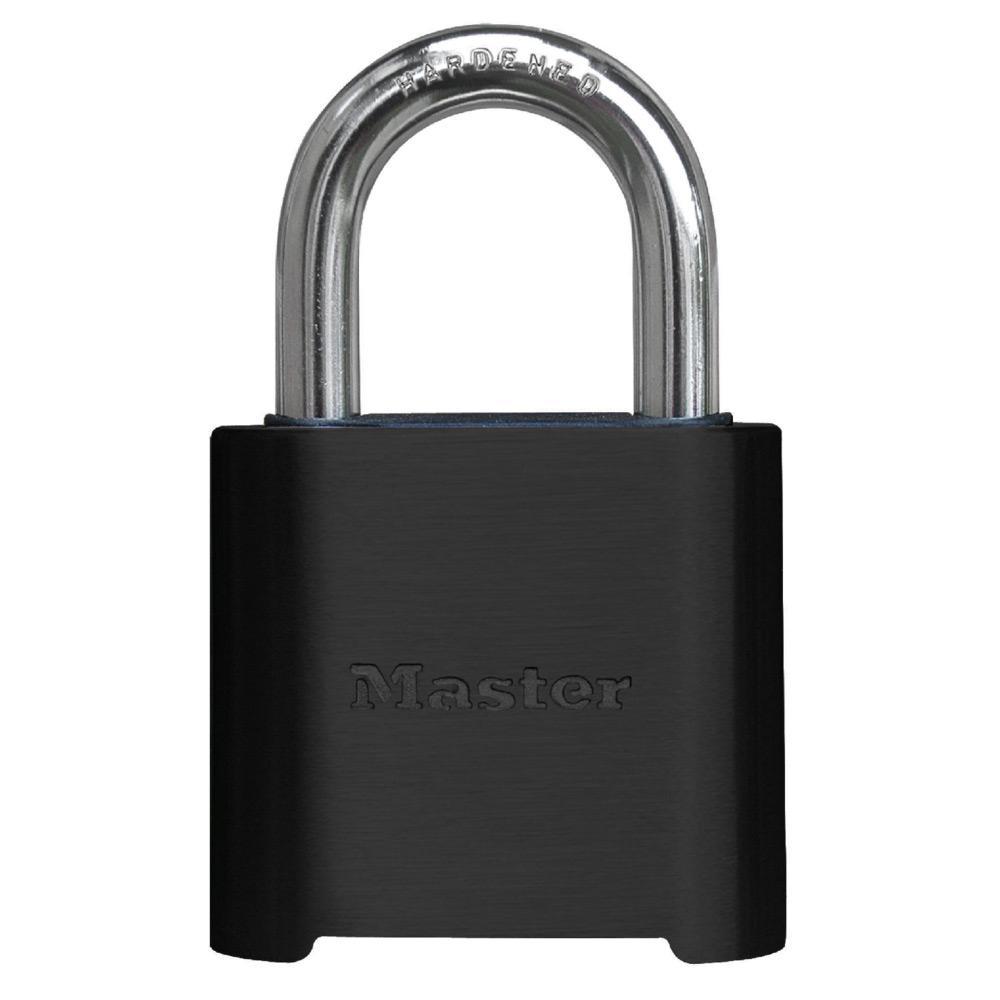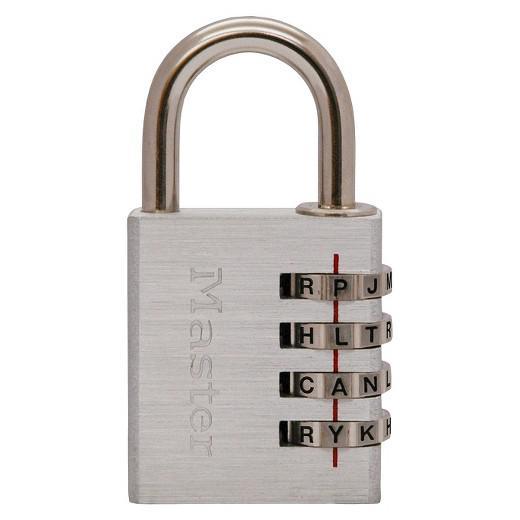The first image is the image on the left, the second image is the image on the right. For the images displayed, is the sentence "There are no less than two black padlocks" factually correct? Answer yes or no. No. The first image is the image on the left, the second image is the image on the right. For the images shown, is this caption "All locks are combination locks, with the number belts visible in the images." true? Answer yes or no. No. 